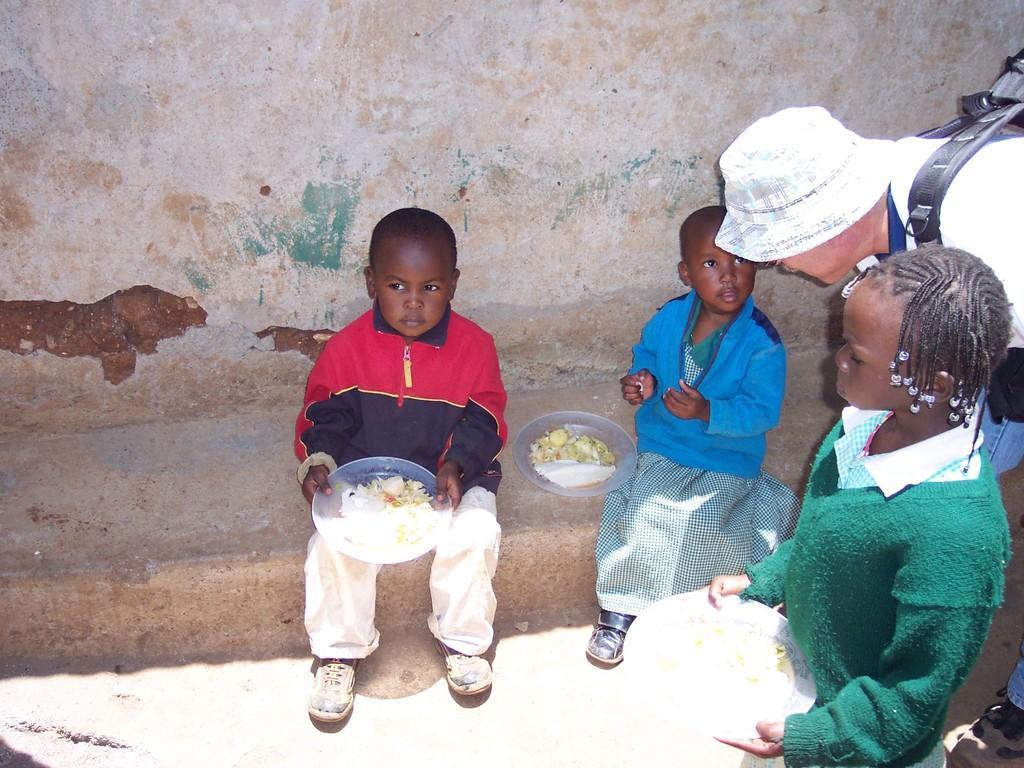Could you give a brief overview of what you see in this image? There are two kids sitting. This boy is holding a plate in his hands. I can see a girl and a person standing. This is the wall. This girl is also holding a plate. 